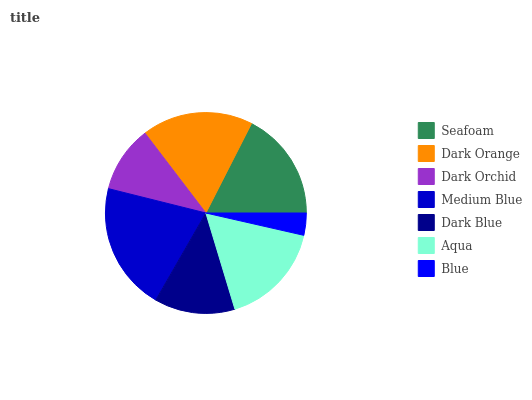Is Blue the minimum?
Answer yes or no. Yes. Is Medium Blue the maximum?
Answer yes or no. Yes. Is Dark Orange the minimum?
Answer yes or no. No. Is Dark Orange the maximum?
Answer yes or no. No. Is Dark Orange greater than Seafoam?
Answer yes or no. Yes. Is Seafoam less than Dark Orange?
Answer yes or no. Yes. Is Seafoam greater than Dark Orange?
Answer yes or no. No. Is Dark Orange less than Seafoam?
Answer yes or no. No. Is Aqua the high median?
Answer yes or no. Yes. Is Aqua the low median?
Answer yes or no. Yes. Is Dark Blue the high median?
Answer yes or no. No. Is Seafoam the low median?
Answer yes or no. No. 